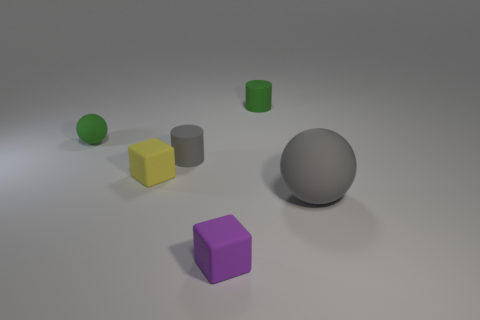Add 3 big red metallic objects. How many objects exist? 9 Subtract all spheres. How many objects are left? 4 Add 3 small gray rubber cylinders. How many small gray rubber cylinders are left? 4 Add 6 small spheres. How many small spheres exist? 7 Subtract 0 brown spheres. How many objects are left? 6 Subtract all purple balls. Subtract all yellow cylinders. How many balls are left? 2 Subtract all large green cylinders. Subtract all small cubes. How many objects are left? 4 